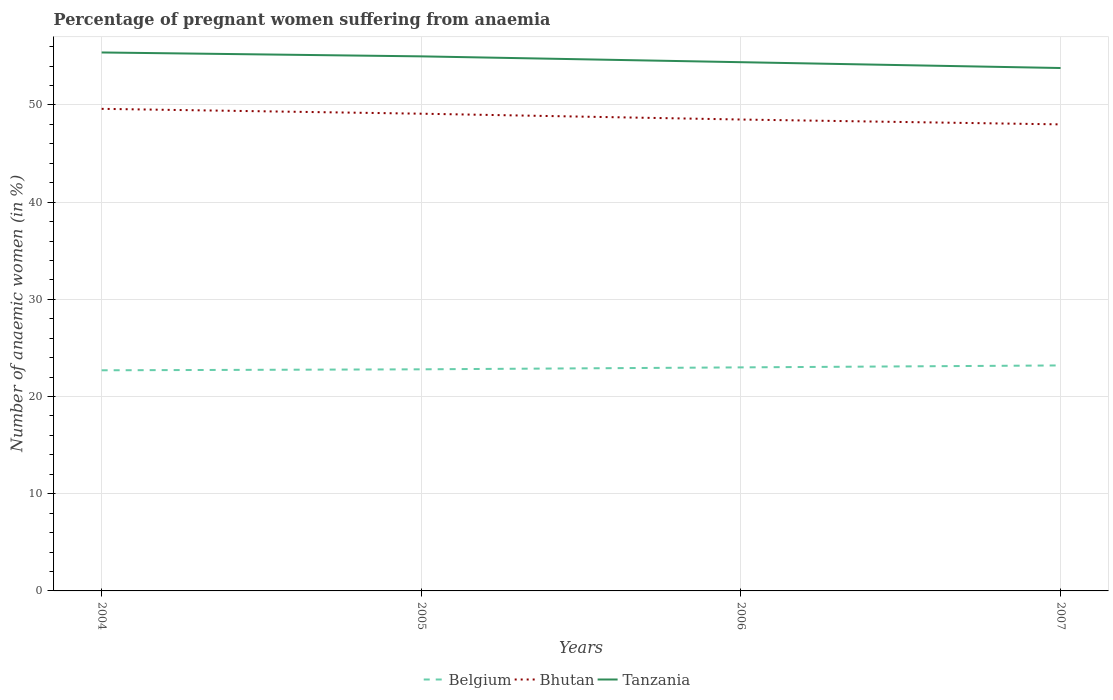Is the number of lines equal to the number of legend labels?
Your response must be concise. Yes. Across all years, what is the maximum number of anaemic women in Bhutan?
Give a very brief answer. 48. In which year was the number of anaemic women in Tanzania maximum?
Your answer should be very brief. 2007. What is the total number of anaemic women in Bhutan in the graph?
Give a very brief answer. 1.6. What is the difference between the highest and the second highest number of anaemic women in Tanzania?
Keep it short and to the point. 1.6. What is the difference between the highest and the lowest number of anaemic women in Tanzania?
Your response must be concise. 2. How many years are there in the graph?
Offer a very short reply. 4. What is the difference between two consecutive major ticks on the Y-axis?
Provide a short and direct response. 10. Are the values on the major ticks of Y-axis written in scientific E-notation?
Make the answer very short. No. Where does the legend appear in the graph?
Your response must be concise. Bottom center. How many legend labels are there?
Ensure brevity in your answer.  3. How are the legend labels stacked?
Your response must be concise. Horizontal. What is the title of the graph?
Your response must be concise. Percentage of pregnant women suffering from anaemia. Does "Vietnam" appear as one of the legend labels in the graph?
Offer a very short reply. No. What is the label or title of the Y-axis?
Keep it short and to the point. Number of anaemic women (in %). What is the Number of anaemic women (in %) of Belgium in 2004?
Your answer should be compact. 22.7. What is the Number of anaemic women (in %) of Bhutan in 2004?
Offer a very short reply. 49.6. What is the Number of anaemic women (in %) in Tanzania in 2004?
Provide a succinct answer. 55.4. What is the Number of anaemic women (in %) in Belgium in 2005?
Keep it short and to the point. 22.8. What is the Number of anaemic women (in %) in Bhutan in 2005?
Provide a succinct answer. 49.1. What is the Number of anaemic women (in %) of Tanzania in 2005?
Offer a terse response. 55. What is the Number of anaemic women (in %) of Bhutan in 2006?
Provide a short and direct response. 48.5. What is the Number of anaemic women (in %) in Tanzania in 2006?
Offer a very short reply. 54.4. What is the Number of anaemic women (in %) in Belgium in 2007?
Keep it short and to the point. 23.2. What is the Number of anaemic women (in %) in Bhutan in 2007?
Make the answer very short. 48. What is the Number of anaemic women (in %) of Tanzania in 2007?
Your answer should be compact. 53.8. Across all years, what is the maximum Number of anaemic women (in %) in Belgium?
Your answer should be compact. 23.2. Across all years, what is the maximum Number of anaemic women (in %) in Bhutan?
Your answer should be very brief. 49.6. Across all years, what is the maximum Number of anaemic women (in %) in Tanzania?
Your response must be concise. 55.4. Across all years, what is the minimum Number of anaemic women (in %) of Belgium?
Your response must be concise. 22.7. Across all years, what is the minimum Number of anaemic women (in %) of Bhutan?
Keep it short and to the point. 48. Across all years, what is the minimum Number of anaemic women (in %) in Tanzania?
Your answer should be very brief. 53.8. What is the total Number of anaemic women (in %) of Belgium in the graph?
Your answer should be compact. 91.7. What is the total Number of anaemic women (in %) of Bhutan in the graph?
Give a very brief answer. 195.2. What is the total Number of anaemic women (in %) in Tanzania in the graph?
Provide a succinct answer. 218.6. What is the difference between the Number of anaemic women (in %) in Bhutan in 2004 and that in 2005?
Ensure brevity in your answer.  0.5. What is the difference between the Number of anaemic women (in %) in Tanzania in 2004 and that in 2005?
Make the answer very short. 0.4. What is the difference between the Number of anaemic women (in %) in Bhutan in 2004 and that in 2006?
Ensure brevity in your answer.  1.1. What is the difference between the Number of anaemic women (in %) in Belgium in 2004 and that in 2007?
Make the answer very short. -0.5. What is the difference between the Number of anaemic women (in %) in Tanzania in 2004 and that in 2007?
Your answer should be compact. 1.6. What is the difference between the Number of anaemic women (in %) in Belgium in 2005 and that in 2006?
Offer a terse response. -0.2. What is the difference between the Number of anaemic women (in %) of Belgium in 2005 and that in 2007?
Make the answer very short. -0.4. What is the difference between the Number of anaemic women (in %) of Tanzania in 2005 and that in 2007?
Provide a short and direct response. 1.2. What is the difference between the Number of anaemic women (in %) of Bhutan in 2006 and that in 2007?
Give a very brief answer. 0.5. What is the difference between the Number of anaemic women (in %) of Belgium in 2004 and the Number of anaemic women (in %) of Bhutan in 2005?
Provide a short and direct response. -26.4. What is the difference between the Number of anaemic women (in %) in Belgium in 2004 and the Number of anaemic women (in %) in Tanzania in 2005?
Keep it short and to the point. -32.3. What is the difference between the Number of anaemic women (in %) of Bhutan in 2004 and the Number of anaemic women (in %) of Tanzania in 2005?
Offer a terse response. -5.4. What is the difference between the Number of anaemic women (in %) in Belgium in 2004 and the Number of anaemic women (in %) in Bhutan in 2006?
Your answer should be compact. -25.8. What is the difference between the Number of anaemic women (in %) in Belgium in 2004 and the Number of anaemic women (in %) in Tanzania in 2006?
Offer a terse response. -31.7. What is the difference between the Number of anaemic women (in %) in Belgium in 2004 and the Number of anaemic women (in %) in Bhutan in 2007?
Make the answer very short. -25.3. What is the difference between the Number of anaemic women (in %) in Belgium in 2004 and the Number of anaemic women (in %) in Tanzania in 2007?
Provide a short and direct response. -31.1. What is the difference between the Number of anaemic women (in %) in Bhutan in 2004 and the Number of anaemic women (in %) in Tanzania in 2007?
Your answer should be very brief. -4.2. What is the difference between the Number of anaemic women (in %) in Belgium in 2005 and the Number of anaemic women (in %) in Bhutan in 2006?
Your response must be concise. -25.7. What is the difference between the Number of anaemic women (in %) in Belgium in 2005 and the Number of anaemic women (in %) in Tanzania in 2006?
Your answer should be compact. -31.6. What is the difference between the Number of anaemic women (in %) in Belgium in 2005 and the Number of anaemic women (in %) in Bhutan in 2007?
Offer a very short reply. -25.2. What is the difference between the Number of anaemic women (in %) in Belgium in 2005 and the Number of anaemic women (in %) in Tanzania in 2007?
Provide a short and direct response. -31. What is the difference between the Number of anaemic women (in %) of Bhutan in 2005 and the Number of anaemic women (in %) of Tanzania in 2007?
Your answer should be compact. -4.7. What is the difference between the Number of anaemic women (in %) in Belgium in 2006 and the Number of anaemic women (in %) in Tanzania in 2007?
Offer a terse response. -30.8. What is the difference between the Number of anaemic women (in %) of Bhutan in 2006 and the Number of anaemic women (in %) of Tanzania in 2007?
Provide a succinct answer. -5.3. What is the average Number of anaemic women (in %) in Belgium per year?
Offer a very short reply. 22.93. What is the average Number of anaemic women (in %) in Bhutan per year?
Your response must be concise. 48.8. What is the average Number of anaemic women (in %) of Tanzania per year?
Give a very brief answer. 54.65. In the year 2004, what is the difference between the Number of anaemic women (in %) in Belgium and Number of anaemic women (in %) in Bhutan?
Keep it short and to the point. -26.9. In the year 2004, what is the difference between the Number of anaemic women (in %) in Belgium and Number of anaemic women (in %) in Tanzania?
Keep it short and to the point. -32.7. In the year 2004, what is the difference between the Number of anaemic women (in %) of Bhutan and Number of anaemic women (in %) of Tanzania?
Offer a very short reply. -5.8. In the year 2005, what is the difference between the Number of anaemic women (in %) in Belgium and Number of anaemic women (in %) in Bhutan?
Your answer should be compact. -26.3. In the year 2005, what is the difference between the Number of anaemic women (in %) in Belgium and Number of anaemic women (in %) in Tanzania?
Give a very brief answer. -32.2. In the year 2005, what is the difference between the Number of anaemic women (in %) in Bhutan and Number of anaemic women (in %) in Tanzania?
Offer a very short reply. -5.9. In the year 2006, what is the difference between the Number of anaemic women (in %) in Belgium and Number of anaemic women (in %) in Bhutan?
Your response must be concise. -25.5. In the year 2006, what is the difference between the Number of anaemic women (in %) of Belgium and Number of anaemic women (in %) of Tanzania?
Your answer should be very brief. -31.4. In the year 2007, what is the difference between the Number of anaemic women (in %) of Belgium and Number of anaemic women (in %) of Bhutan?
Make the answer very short. -24.8. In the year 2007, what is the difference between the Number of anaemic women (in %) in Belgium and Number of anaemic women (in %) in Tanzania?
Your answer should be very brief. -30.6. In the year 2007, what is the difference between the Number of anaemic women (in %) of Bhutan and Number of anaemic women (in %) of Tanzania?
Your answer should be compact. -5.8. What is the ratio of the Number of anaemic women (in %) in Bhutan in 2004 to that in 2005?
Make the answer very short. 1.01. What is the ratio of the Number of anaemic women (in %) in Tanzania in 2004 to that in 2005?
Your response must be concise. 1.01. What is the ratio of the Number of anaemic women (in %) in Belgium in 2004 to that in 2006?
Your response must be concise. 0.99. What is the ratio of the Number of anaemic women (in %) of Bhutan in 2004 to that in 2006?
Offer a terse response. 1.02. What is the ratio of the Number of anaemic women (in %) of Tanzania in 2004 to that in 2006?
Keep it short and to the point. 1.02. What is the ratio of the Number of anaemic women (in %) of Belgium in 2004 to that in 2007?
Your answer should be compact. 0.98. What is the ratio of the Number of anaemic women (in %) of Bhutan in 2004 to that in 2007?
Your answer should be very brief. 1.03. What is the ratio of the Number of anaemic women (in %) of Tanzania in 2004 to that in 2007?
Keep it short and to the point. 1.03. What is the ratio of the Number of anaemic women (in %) in Belgium in 2005 to that in 2006?
Give a very brief answer. 0.99. What is the ratio of the Number of anaemic women (in %) of Bhutan in 2005 to that in 2006?
Your response must be concise. 1.01. What is the ratio of the Number of anaemic women (in %) of Tanzania in 2005 to that in 2006?
Your response must be concise. 1.01. What is the ratio of the Number of anaemic women (in %) in Belgium in 2005 to that in 2007?
Keep it short and to the point. 0.98. What is the ratio of the Number of anaemic women (in %) of Bhutan in 2005 to that in 2007?
Ensure brevity in your answer.  1.02. What is the ratio of the Number of anaemic women (in %) in Tanzania in 2005 to that in 2007?
Your response must be concise. 1.02. What is the ratio of the Number of anaemic women (in %) of Belgium in 2006 to that in 2007?
Provide a succinct answer. 0.99. What is the ratio of the Number of anaemic women (in %) in Bhutan in 2006 to that in 2007?
Your response must be concise. 1.01. What is the ratio of the Number of anaemic women (in %) in Tanzania in 2006 to that in 2007?
Keep it short and to the point. 1.01. What is the difference between the highest and the second highest Number of anaemic women (in %) in Belgium?
Ensure brevity in your answer.  0.2. What is the difference between the highest and the second highest Number of anaemic women (in %) of Bhutan?
Your response must be concise. 0.5. What is the difference between the highest and the second highest Number of anaemic women (in %) in Tanzania?
Offer a terse response. 0.4. What is the difference between the highest and the lowest Number of anaemic women (in %) in Belgium?
Give a very brief answer. 0.5. What is the difference between the highest and the lowest Number of anaemic women (in %) of Tanzania?
Make the answer very short. 1.6. 